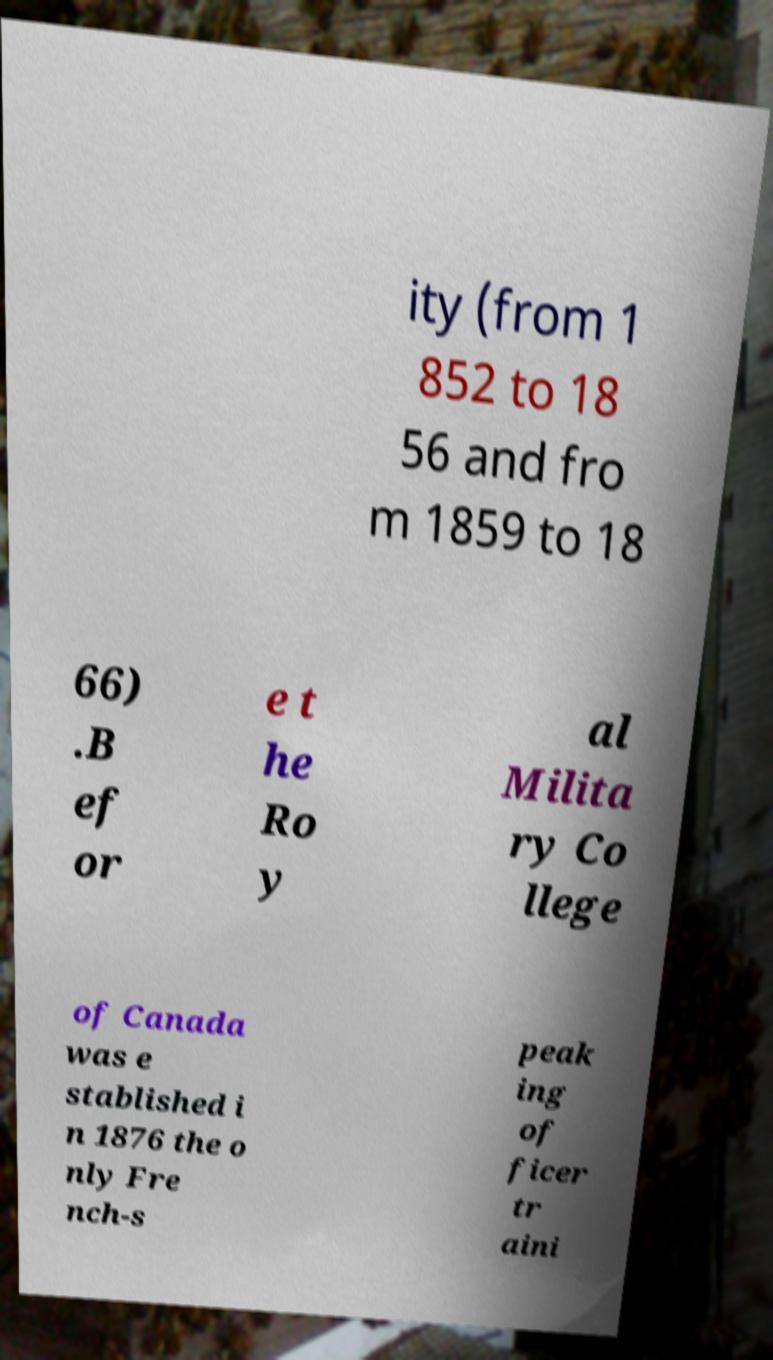For documentation purposes, I need the text within this image transcribed. Could you provide that? ity (from 1 852 to 18 56 and fro m 1859 to 18 66) .B ef or e t he Ro y al Milita ry Co llege of Canada was e stablished i n 1876 the o nly Fre nch-s peak ing of ficer tr aini 